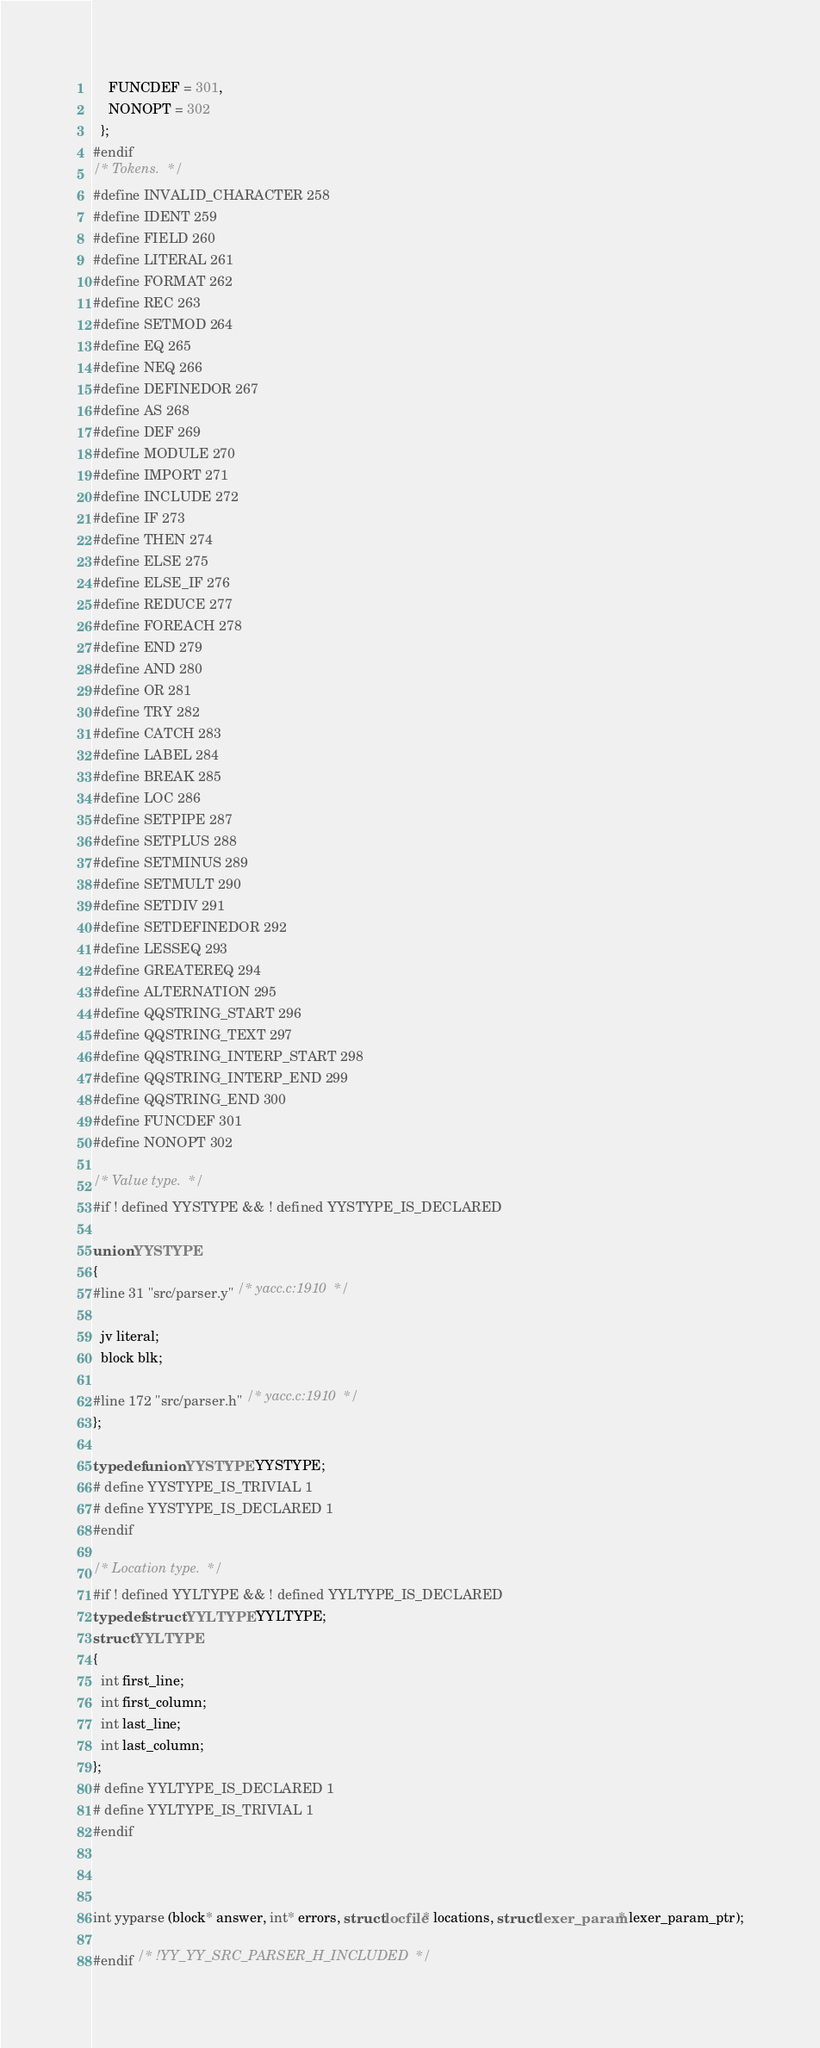Convert code to text. <code><loc_0><loc_0><loc_500><loc_500><_C_>    FUNCDEF = 301,
    NONOPT = 302
  };
#endif
/* Tokens.  */
#define INVALID_CHARACTER 258
#define IDENT 259
#define FIELD 260
#define LITERAL 261
#define FORMAT 262
#define REC 263
#define SETMOD 264
#define EQ 265
#define NEQ 266
#define DEFINEDOR 267
#define AS 268
#define DEF 269
#define MODULE 270
#define IMPORT 271
#define INCLUDE 272
#define IF 273
#define THEN 274
#define ELSE 275
#define ELSE_IF 276
#define REDUCE 277
#define FOREACH 278
#define END 279
#define AND 280
#define OR 281
#define TRY 282
#define CATCH 283
#define LABEL 284
#define BREAK 285
#define LOC 286
#define SETPIPE 287
#define SETPLUS 288
#define SETMINUS 289
#define SETMULT 290
#define SETDIV 291
#define SETDEFINEDOR 292
#define LESSEQ 293
#define GREATEREQ 294
#define ALTERNATION 295
#define QQSTRING_START 296
#define QQSTRING_TEXT 297
#define QQSTRING_INTERP_START 298
#define QQSTRING_INTERP_END 299
#define QQSTRING_END 300
#define FUNCDEF 301
#define NONOPT 302

/* Value type.  */
#if ! defined YYSTYPE && ! defined YYSTYPE_IS_DECLARED

union YYSTYPE
{
#line 31 "src/parser.y" /* yacc.c:1910  */

  jv literal;
  block blk;

#line 172 "src/parser.h" /* yacc.c:1910  */
};

typedef union YYSTYPE YYSTYPE;
# define YYSTYPE_IS_TRIVIAL 1
# define YYSTYPE_IS_DECLARED 1
#endif

/* Location type.  */
#if ! defined YYLTYPE && ! defined YYLTYPE_IS_DECLARED
typedef struct YYLTYPE YYLTYPE;
struct YYLTYPE
{
  int first_line;
  int first_column;
  int last_line;
  int last_column;
};
# define YYLTYPE_IS_DECLARED 1
# define YYLTYPE_IS_TRIVIAL 1
#endif



int yyparse (block* answer, int* errors, struct locfile* locations, struct lexer_param* lexer_param_ptr);

#endif /* !YY_YY_SRC_PARSER_H_INCLUDED  */
</code> 